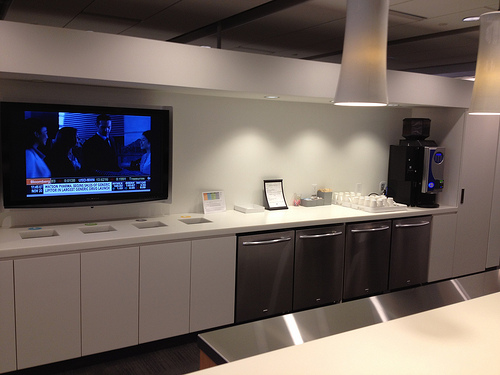Can you suggest an innovative layout change for this room? Reimagining the layout of this room involves creating distinct zones for different activities. The left side could serve as a beverage and snack preparation station, equipped with the latest smart kitchen appliances. The middle section may become a dining area, boasting a sleek island countertop combined with high chairs for quick bites. The right end could be transformed into a lounging corner, with comfy seating arrangements, some light reading material, and possibly a smart, interactive educational system for continuous learning. This multi-zone layout would make the room more versatile and cater to varied needs, enhancing its functionality. What elements in the room suggest a minimalist design approach? The room's minimalist design is suggested by the clean lines and lack of clutter. The white cabinets and countertops contribute to a sense of simplicity and space. The appliances are integrated seamlessly into the cabinetry, maintaining a tidy look. The neutral color palette and the unobtrusive placement of items like the television and the coffee dispenser reinforce the minimalist aesthetic. Let’s go wild: What if this room was part of a spaceship's break area? If this room were part of a spaceship's break area, it would boast advanced technology beyond current imagination. The coffee dispenser would serve an array of concoctions made from intergalactic ingredients. The counters and cabinets would have smart surface technology, revealing hidden compartments and advanced food preparation tools at a touch. The television might be a holographic interface, providing updates on space missions, entertainment, and communication with loved ones light-years away. The lighting would adapt to simulate day and night cycles of various planets, helping the crew maintain their circadian rhythms in space. Walls could feature views of distant galaxies, creating a sense of awe and relaxation amid the vastness of space. 